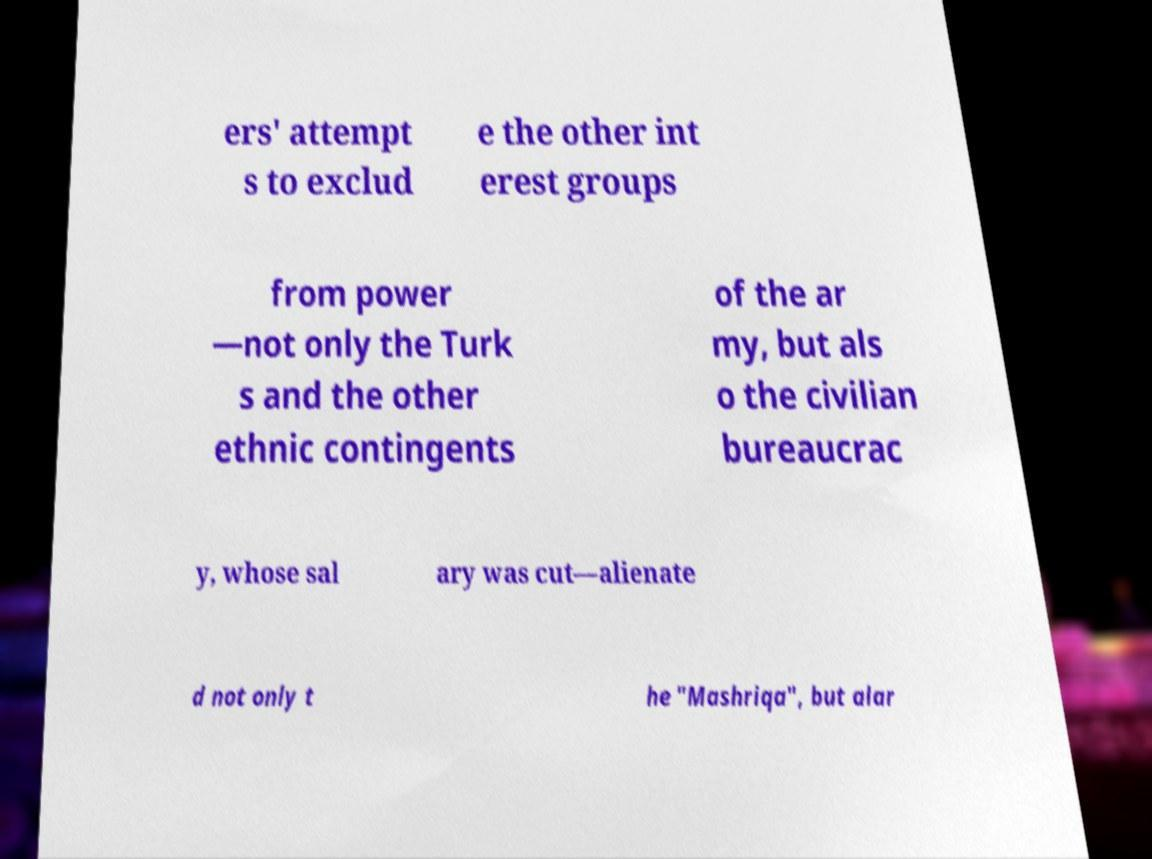For documentation purposes, I need the text within this image transcribed. Could you provide that? ers' attempt s to exclud e the other int erest groups from power —not only the Turk s and the other ethnic contingents of the ar my, but als o the civilian bureaucrac y, whose sal ary was cut—alienate d not only t he "Mashriqa", but alar 